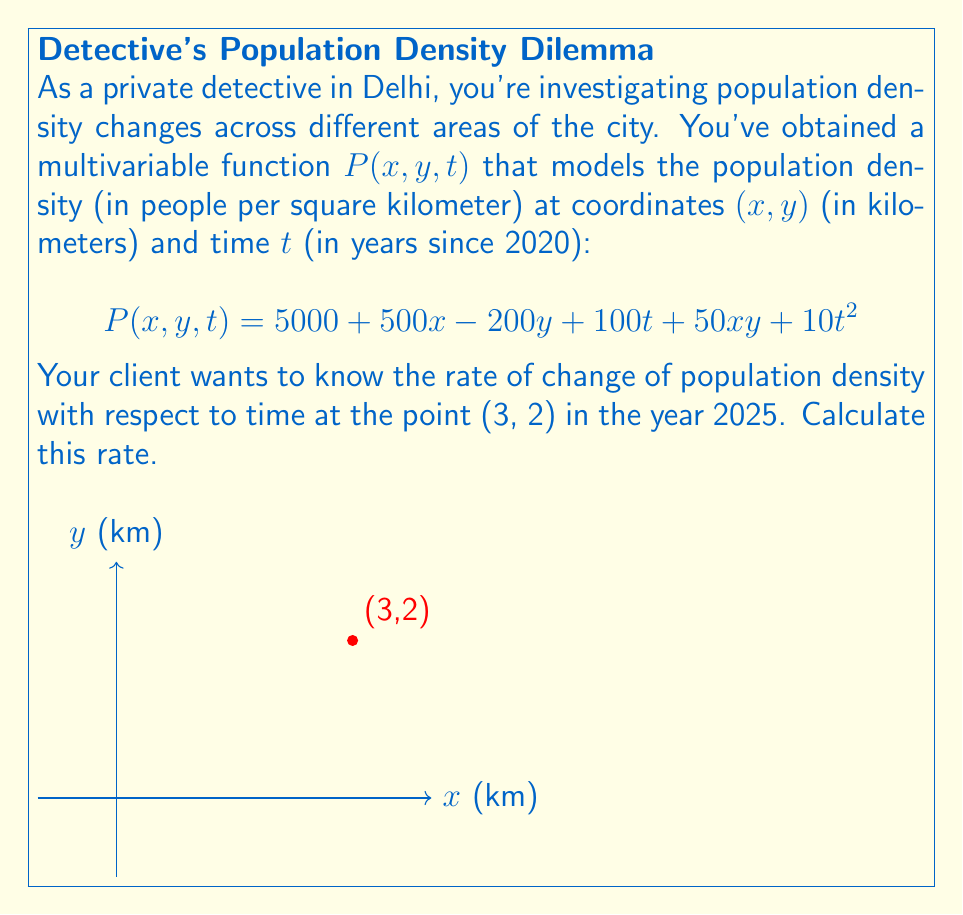Show me your answer to this math problem. To solve this problem, we need to follow these steps:

1) The rate of change of population density with respect to time is given by the partial derivative of $P$ with respect to $t$:

   $$\frac{\partial P}{\partial t} = 100 + 20t$$

2) We need to evaluate this at the point (3, 2) and at t = 5 (since 2025 is 5 years after 2020).

3) Substituting t = 5 into the partial derivative:

   $$\frac{\partial P}{\partial t}\bigg|_{t=5} = 100 + 20(5) = 100 + 100 = 200$$

4) This result gives us the rate of change of population density with respect to time at any point $(x,y)$ in 2025.

5) The question specifically asks for the point (3, 2), but note that the rate of change with respect to time doesn't depend on x and y in this model.

Therefore, the rate of change of population density with respect to time at the point (3, 2) in 2025 is 200 people per square kilometer per year.
Answer: 200 people/km²/year 